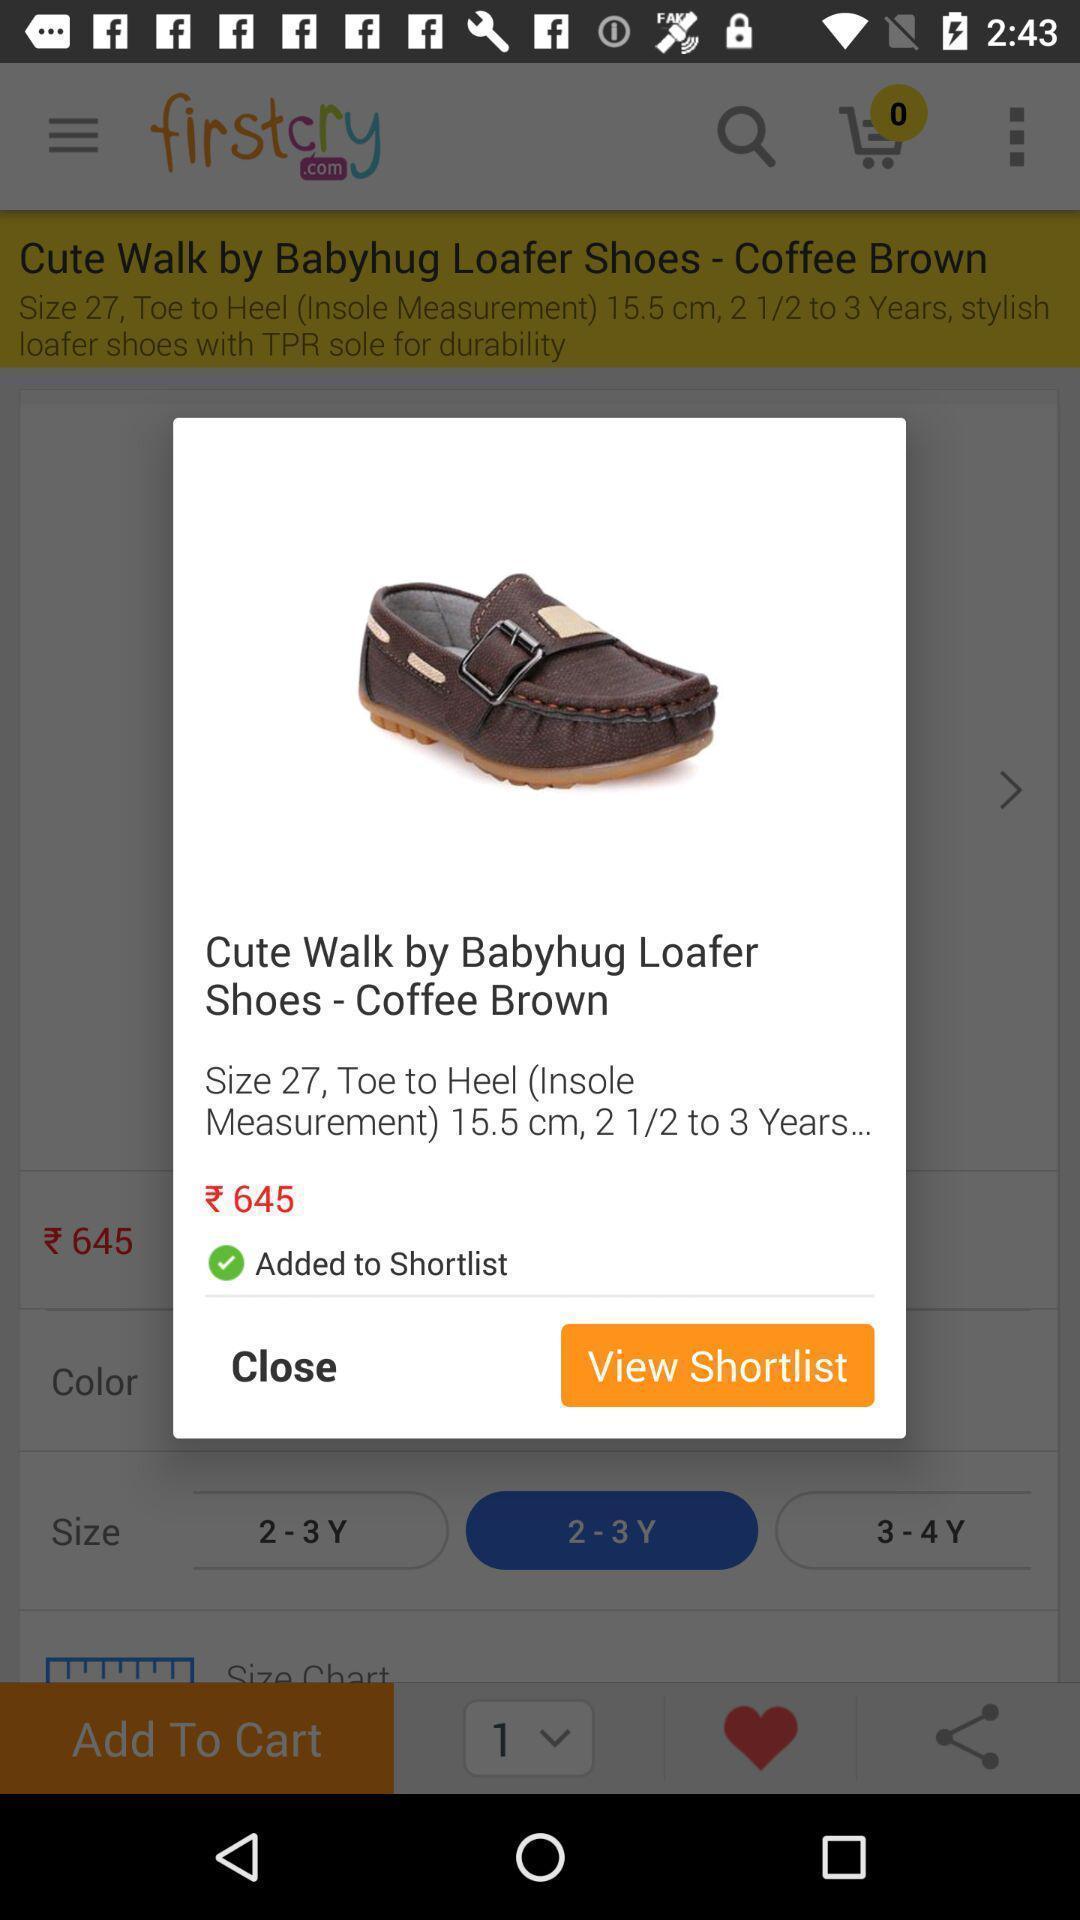Describe this image in words. Popup shows a product with price in the shopping app. 